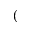<formula> <loc_0><loc_0><loc_500><loc_500>(</formula> 